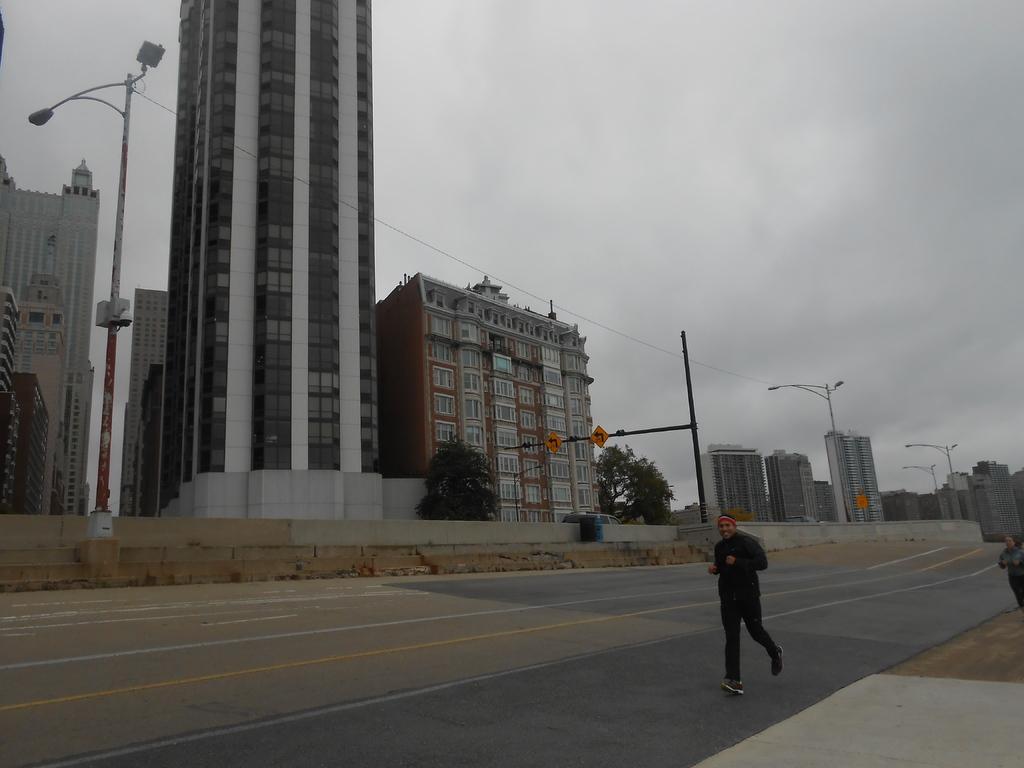Describe this image in one or two sentences. In this image we can see a man running on the road. Here we can see poles, trees, boards, wall, and buildings. In the background there is sky with clouds. On the right side of the image we can see a person. 